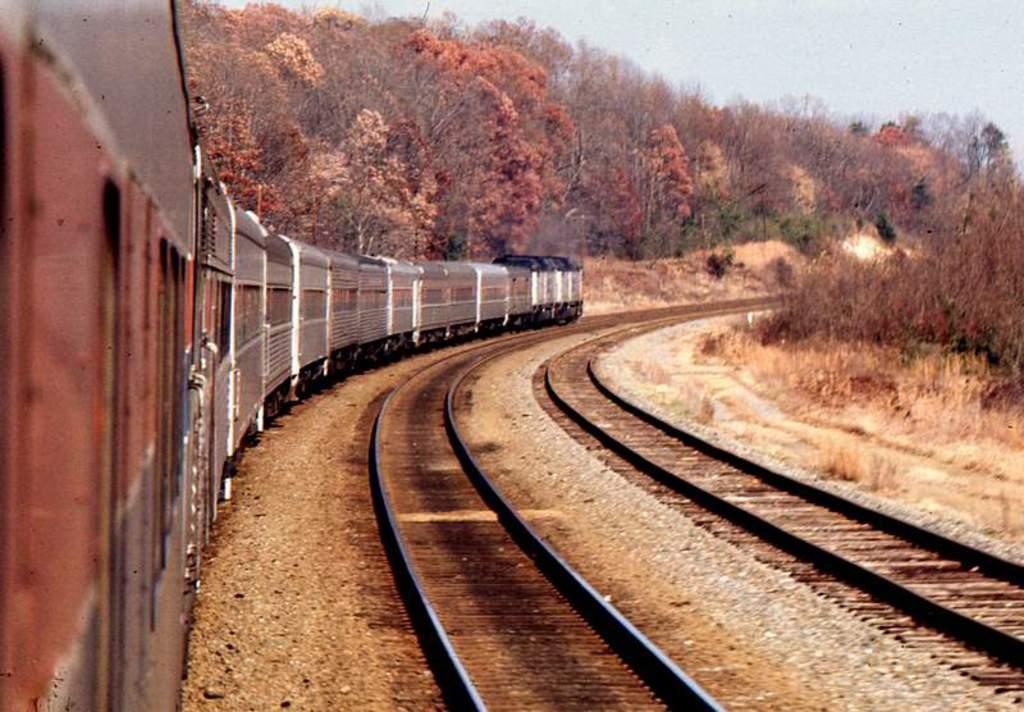Describe this image in one or two sentences. In this image there is a train on the railway track. On the right side there are two other tracks. In the background there are trees on either side of the train. At the bottom there is sand on which there are stones. 